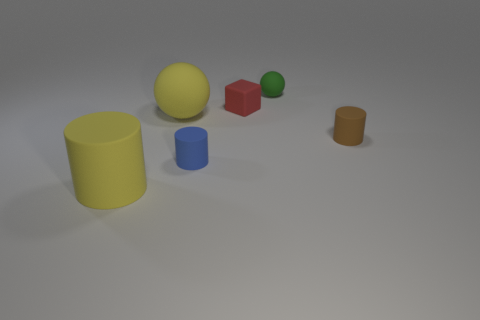There is a tiny matte thing that is in front of the small matte block and on the right side of the blue cylinder; what is its color?
Your answer should be compact. Brown. Does the green object have the same size as the ball that is in front of the red thing?
Your answer should be very brief. No. Is there anything else that is the same shape as the small red thing?
Your response must be concise. No. There is another big object that is the same shape as the blue object; what is its color?
Ensure brevity in your answer.  Yellow. Does the brown rubber cylinder have the same size as the red cube?
Provide a succinct answer. Yes. What number of other things are the same size as the blue cylinder?
Keep it short and to the point. 3. What number of objects are red rubber things on the left side of the tiny green matte thing or tiny rubber cylinders that are to the right of the blue matte thing?
Keep it short and to the point. 2. There is a green object that is the same size as the blue rubber cylinder; what shape is it?
Keep it short and to the point. Sphere. What size is the yellow ball that is made of the same material as the green ball?
Your answer should be compact. Large. Does the small blue matte thing have the same shape as the tiny brown object?
Provide a succinct answer. Yes. 